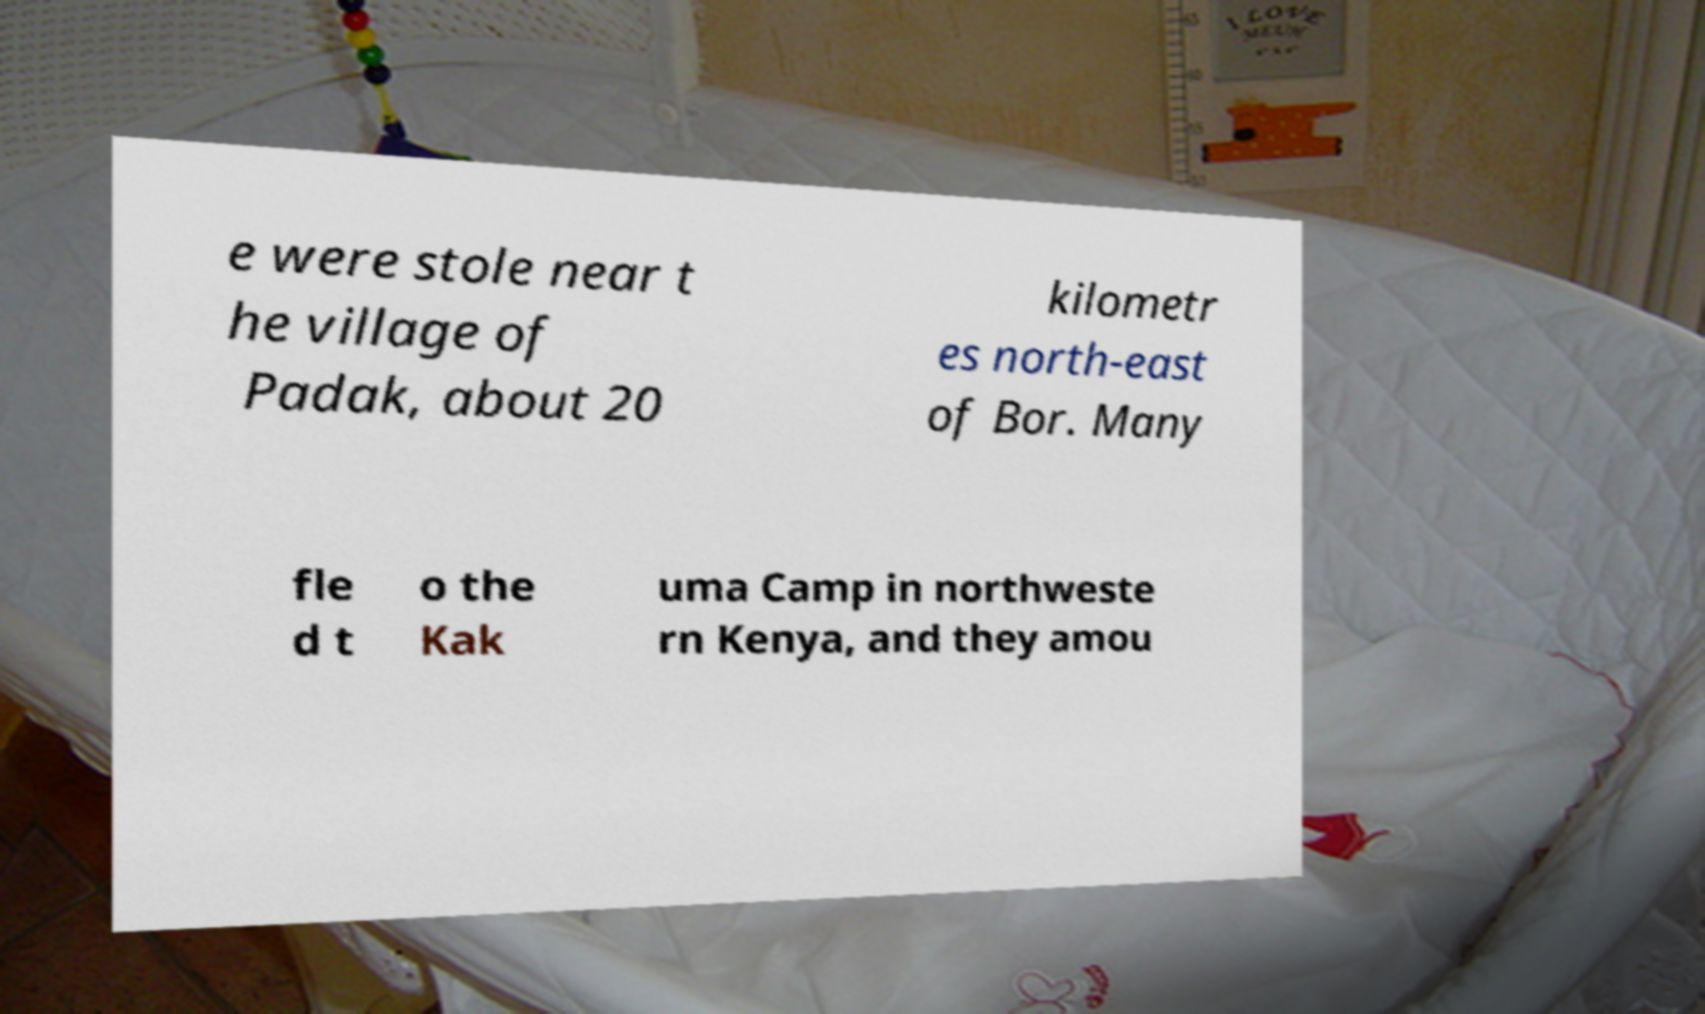What messages or text are displayed in this image? I need them in a readable, typed format. e were stole near t he village of Padak, about 20 kilometr es north-east of Bor. Many fle d t o the Kak uma Camp in northweste rn Kenya, and they amou 